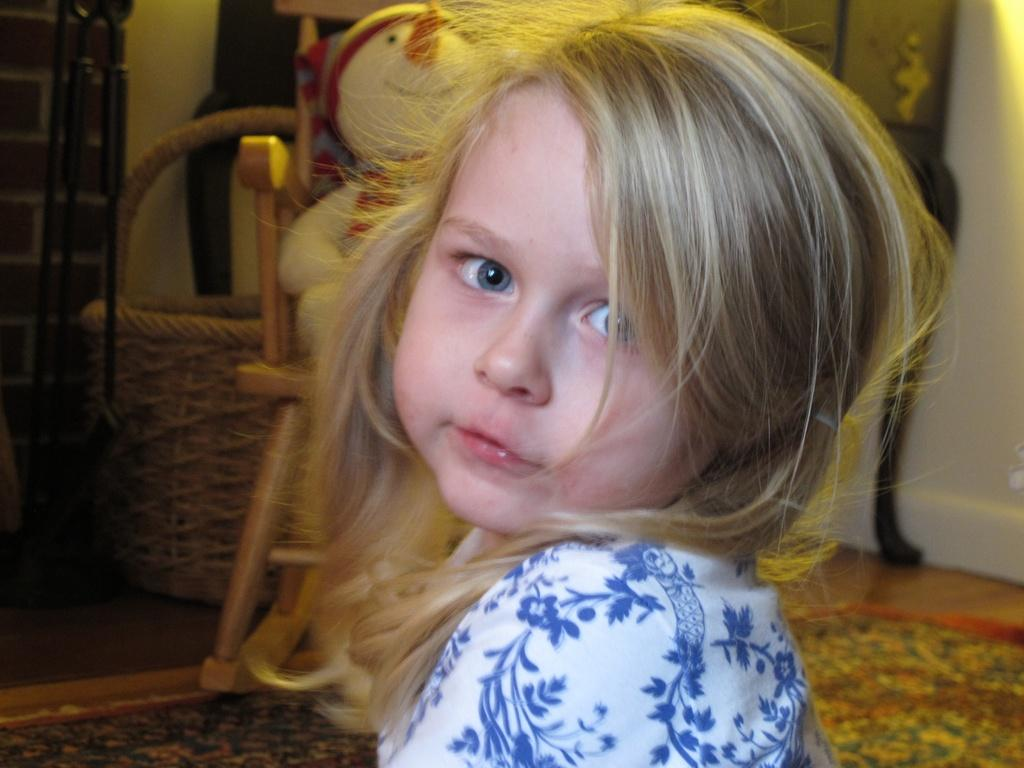What is the main subject of the image? The main subject of the image is a kid. Can you describe what the kid is wearing? The kid is wearing a white and blue dress. What can be seen behind the kid in the image? There is a doll placed on a chair behind the kid. What other objects are visible in the background of the image? There are other objects visible in the background of the image, but their specific details are not mentioned in the provided facts. What type of juice is the kid holding in the image? There is no juice visible in the image; the main subject is a kid wearing a white and blue dress, with a doll placed on a chair behind them. 